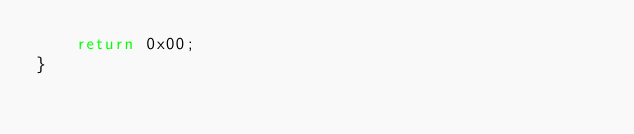<code> <loc_0><loc_0><loc_500><loc_500><_C++_>	return 0x00;
}</code> 